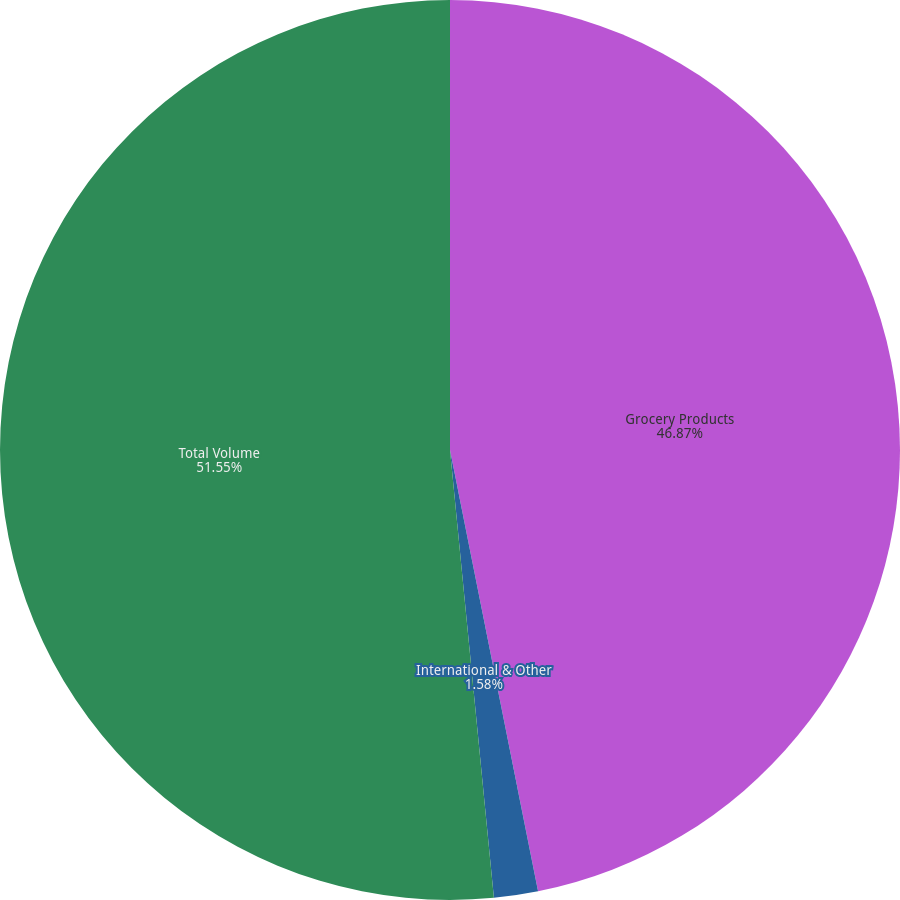Convert chart to OTSL. <chart><loc_0><loc_0><loc_500><loc_500><pie_chart><fcel>Grocery Products<fcel>International & Other<fcel>Total Volume<nl><fcel>46.87%<fcel>1.58%<fcel>51.56%<nl></chart> 